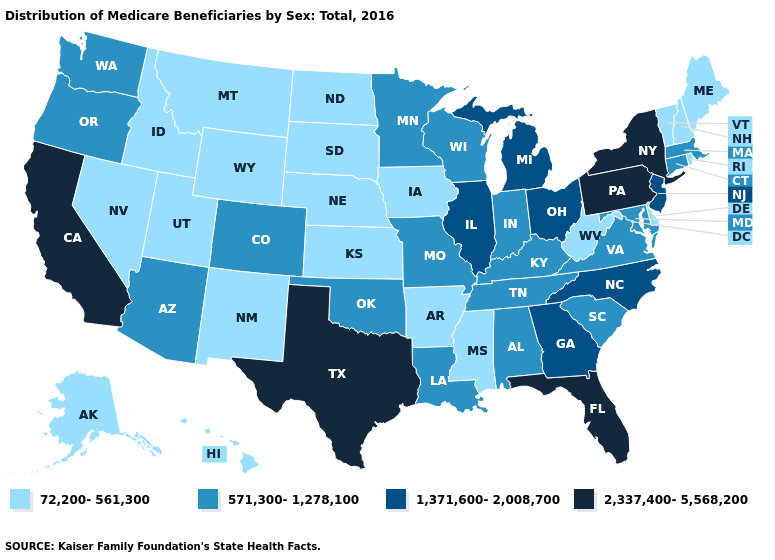Does the map have missing data?
Keep it brief. No. Name the states that have a value in the range 571,300-1,278,100?
Answer briefly. Alabama, Arizona, Colorado, Connecticut, Indiana, Kentucky, Louisiana, Maryland, Massachusetts, Minnesota, Missouri, Oklahoma, Oregon, South Carolina, Tennessee, Virginia, Washington, Wisconsin. Name the states that have a value in the range 2,337,400-5,568,200?
Give a very brief answer. California, Florida, New York, Pennsylvania, Texas. What is the lowest value in the USA?
Keep it brief. 72,200-561,300. Name the states that have a value in the range 72,200-561,300?
Concise answer only. Alaska, Arkansas, Delaware, Hawaii, Idaho, Iowa, Kansas, Maine, Mississippi, Montana, Nebraska, Nevada, New Hampshire, New Mexico, North Dakota, Rhode Island, South Dakota, Utah, Vermont, West Virginia, Wyoming. Name the states that have a value in the range 2,337,400-5,568,200?
Keep it brief. California, Florida, New York, Pennsylvania, Texas. Name the states that have a value in the range 72,200-561,300?
Short answer required. Alaska, Arkansas, Delaware, Hawaii, Idaho, Iowa, Kansas, Maine, Mississippi, Montana, Nebraska, Nevada, New Hampshire, New Mexico, North Dakota, Rhode Island, South Dakota, Utah, Vermont, West Virginia, Wyoming. What is the highest value in states that border Michigan?
Be succinct. 1,371,600-2,008,700. Does Connecticut have a higher value than Nevada?
Keep it brief. Yes. What is the value of Louisiana?
Short answer required. 571,300-1,278,100. Name the states that have a value in the range 1,371,600-2,008,700?
Quick response, please. Georgia, Illinois, Michigan, New Jersey, North Carolina, Ohio. Name the states that have a value in the range 1,371,600-2,008,700?
Quick response, please. Georgia, Illinois, Michigan, New Jersey, North Carolina, Ohio. Name the states that have a value in the range 72,200-561,300?
Answer briefly. Alaska, Arkansas, Delaware, Hawaii, Idaho, Iowa, Kansas, Maine, Mississippi, Montana, Nebraska, Nevada, New Hampshire, New Mexico, North Dakota, Rhode Island, South Dakota, Utah, Vermont, West Virginia, Wyoming. What is the value of California?
Write a very short answer. 2,337,400-5,568,200. What is the value of New Mexico?
Quick response, please. 72,200-561,300. 